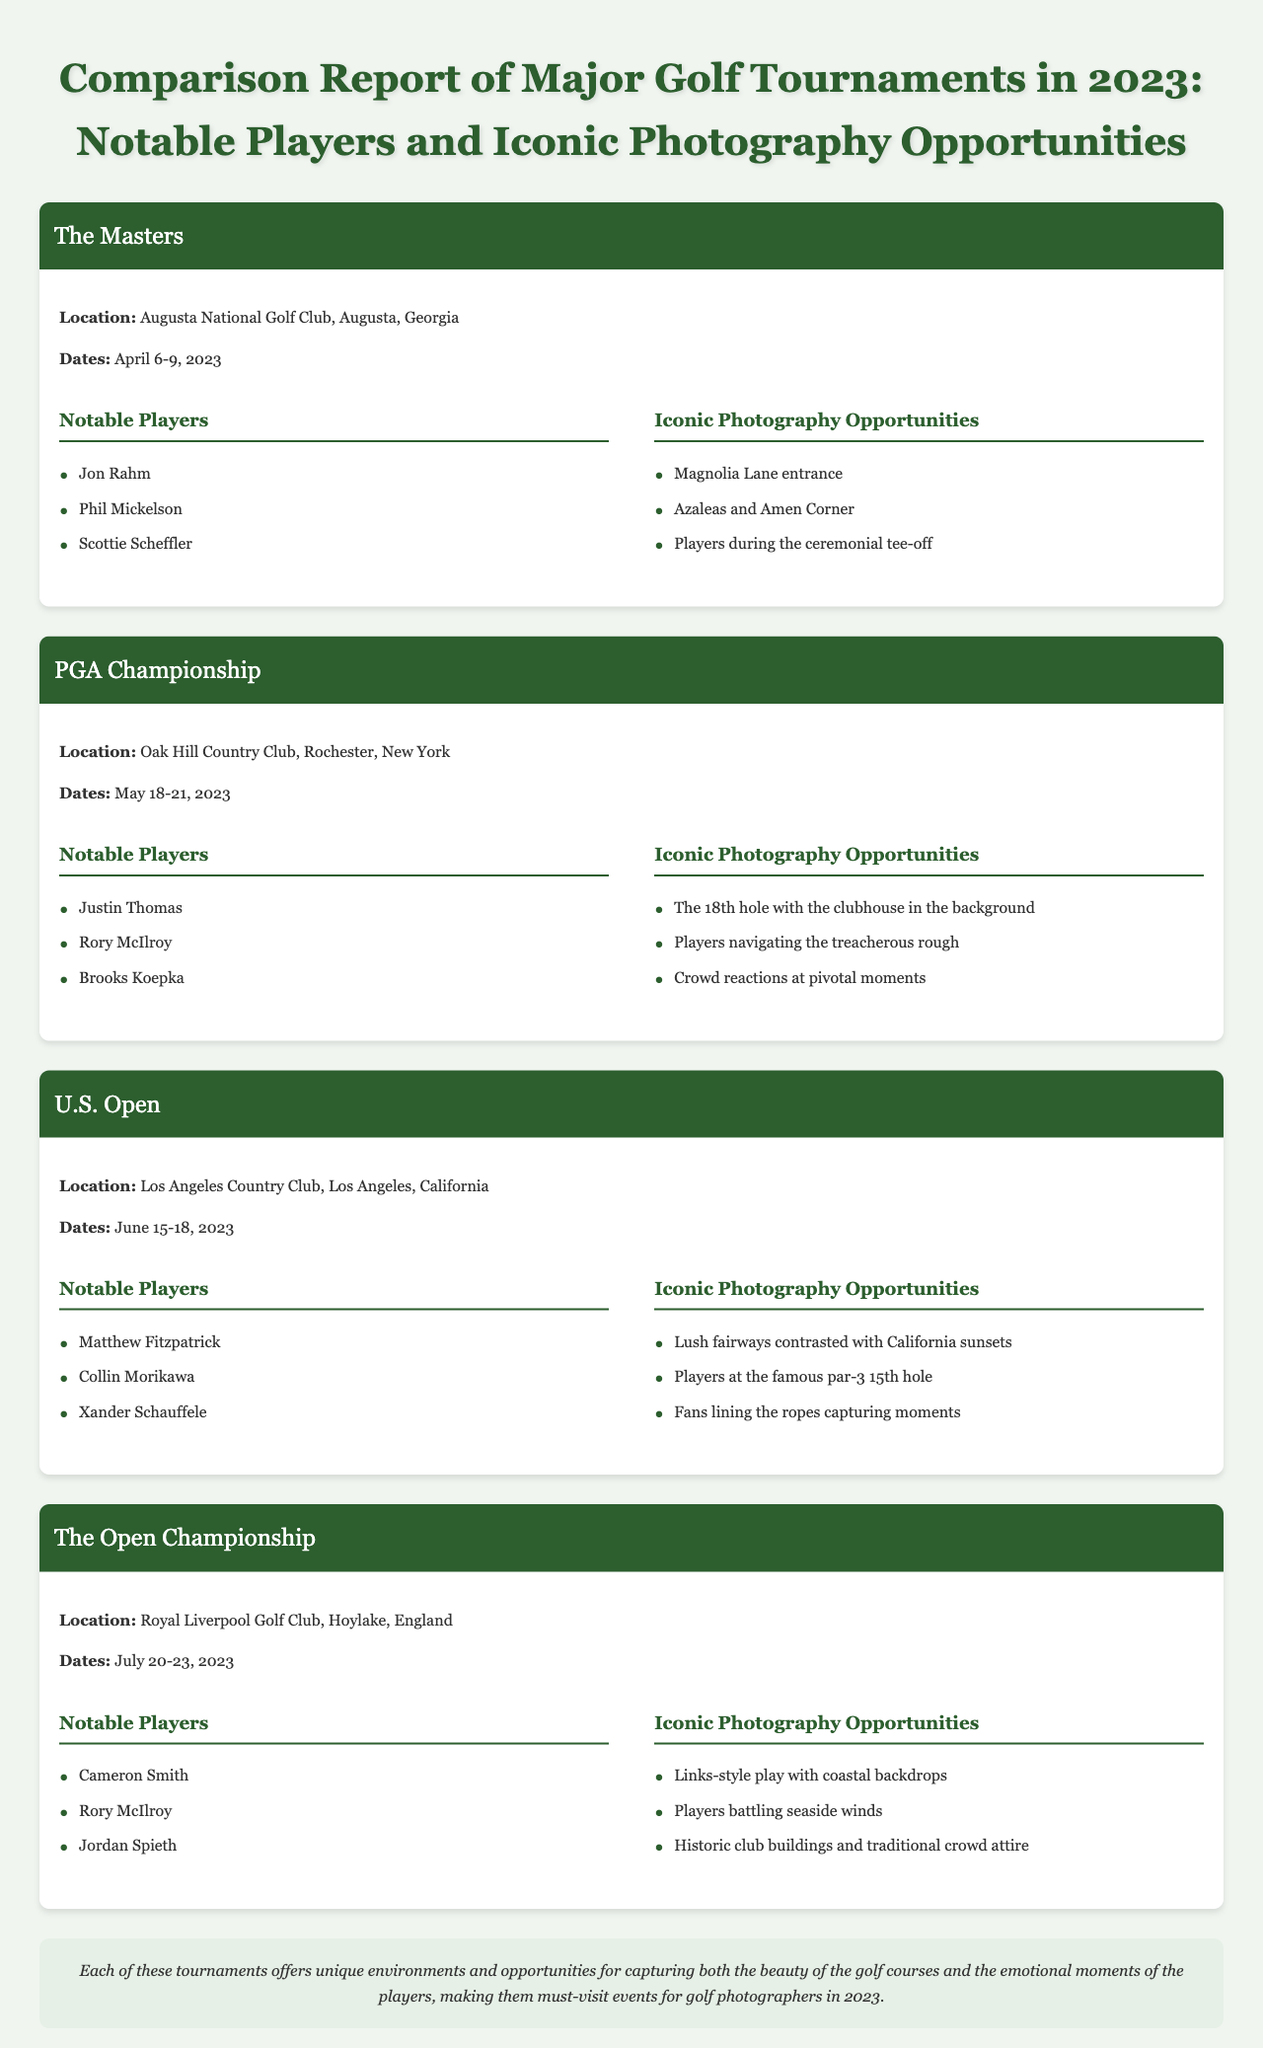What is the location of The Masters? The location is mentioned in the document as Augusta National Golf Club, Augusta, Georgia.
Answer: Augusta National Golf Club, Augusta, Georgia Who were the notable players at the U.S. Open? The document lists Matthew Fitzpatrick, Collin Morikawa, and Xander Schauffele as notable players at the U.S. Open.
Answer: Matthew Fitzpatrick, Collin Morikawa, Xander Schauffele What are the dates of the PGA Championship? The dates are explicitly stated in the document as May 18-21, 2023.
Answer: May 18-21, 2023 Which tournament features the iconic Magnolia Lane entrance? The document specifies that the Magnolia Lane entrance is an iconic photography opportunity at The Masters.
Answer: The Masters What is a recommended photo opportunity at The Open Championship? The document suggests "Links-style play with coastal backdrops" as a photography opportunity at The Open Championship.
Answer: Links-style play with coastal backdrops How many notable players are listed for The Masters? The document mentions three notable players for The Masters, which are Jon Rahm, Phil Mickelson, and Scottie Scheffler.
Answer: Three Where did the U.S. Open take place? The U.S. Open took place at Los Angeles Country Club, Los Angeles, California, according to the document.
Answer: Los Angeles Country Club, Los Angeles, California What is the main theme of the conclusion in the document? The conclusion emphasizes the unique environments and opportunities for capturing beauty and emotion during the tournaments.
Answer: Unique environments and opportunities for capturing beauty and emotion Which player is mentioned as notable in both the PGA Championship and The Open Championship? The document states Rory McIlroy as a notable player in both the PGA Championship and The Open Championship.
Answer: Rory McIlroy 